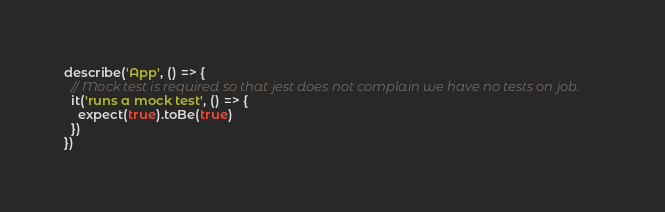<code> <loc_0><loc_0><loc_500><loc_500><_JavaScript_>describe('App', () => {
  // Mock test is required so that jest does not complain we have no tests on job.
  it('runs a mock test', () => {
    expect(true).toBe(true)
  })
})
</code> 